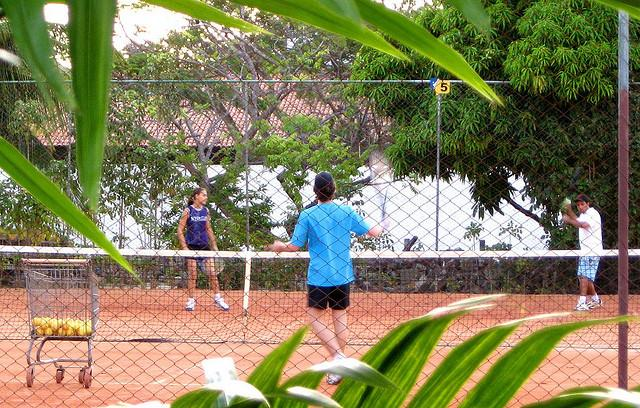What are the tennis balls in the cart for? practice 